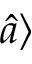Convert formula to latex. <formula><loc_0><loc_0><loc_500><loc_500>\widehat { a } \rangle</formula> 